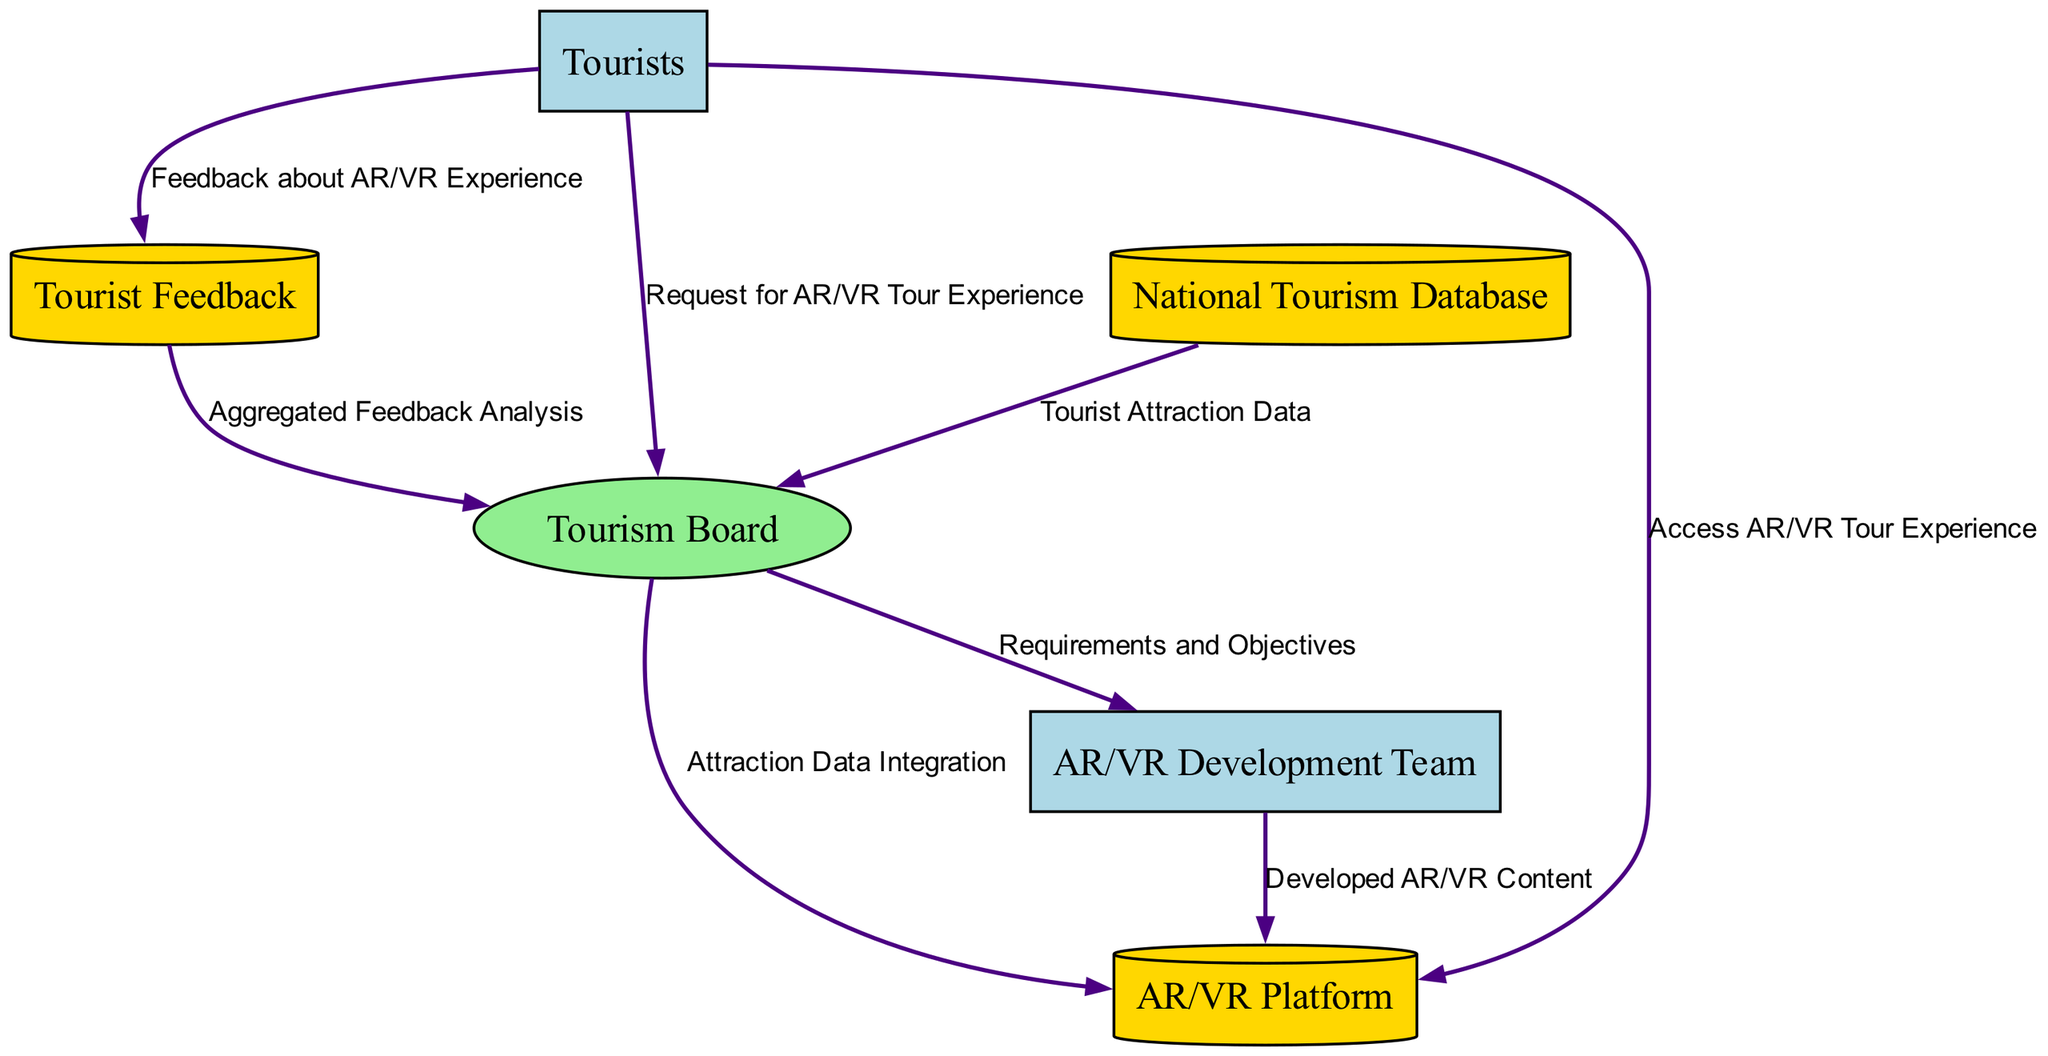What is the external entity that requests the AR/VR tour experience? The diagram shows that the "Tourists" are the external entity that sends a request for the AR/VR tour experience to the "Tourism Board."
Answer: Tourists How many data stores are present in the diagram? The diagram includes three data stores: "National Tourism Database," "Tourist Feedback," and "AR/VR Platform." Therefore, the total number is three.
Answer: 3 What information does the "Tourism Board" send to the "AR/VR Development Team"? According to the flow in the diagram, the "Tourism Board" sends "Requirements and Objectives" to the "AR/VR Development Team."
Answer: Requirements and Objectives From which data store does the "Tourism Board" obtain the "Tourist Attraction Data"? The diagram indicates that the "Tourism Board" retrieves "Tourist Attraction Data" from the "National Tourism Database."
Answer: National Tourism Database What is the final destination of the "Feedback about AR/VR Experience"? The diagram demonstrates that the "Feedback about AR/VR Experience" provided by tourists is sent to the "Tourist Feedback" data store, which then generates the "Aggregated Feedback Analysis" sent to the "Tourism Board."
Answer: Tourism Board Which process receives data from the "National Tourism Database"? The "Tourism Board" receives data from the "National Tourism Database" as indicated in the diagram, showing a direct flow of "Tourist Attraction Data" between them.
Answer: Tourism Board Which external entity accesses the AR/VR tour experience? The diagram shows that "Tourists" access the AR/VR tour experience directly from the "AR/VR Platform."
Answer: Tourists What is the purpose of the data flow from "Tourist Feedback" to the "Tourism Board"? The data flow from "Tourist Feedback" to the "Tourism Board" provides "Aggregated Feedback Analysis," which helps the Tourism Board understand tourist experiences and make decisions accordingly.
Answer: Aggregated Feedback Analysis 